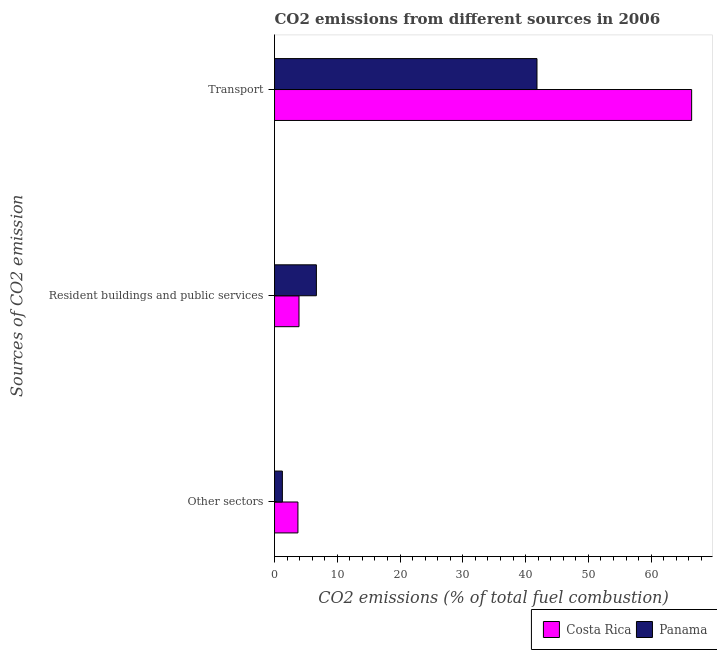How many different coloured bars are there?
Your response must be concise. 2. Are the number of bars per tick equal to the number of legend labels?
Provide a short and direct response. Yes. How many bars are there on the 1st tick from the bottom?
Keep it short and to the point. 2. What is the label of the 2nd group of bars from the top?
Provide a short and direct response. Resident buildings and public services. What is the percentage of co2 emissions from other sectors in Costa Rica?
Your answer should be compact. 3.73. Across all countries, what is the maximum percentage of co2 emissions from other sectors?
Provide a short and direct response. 3.73. Across all countries, what is the minimum percentage of co2 emissions from resident buildings and public services?
Provide a short and direct response. 3.9. In which country was the percentage of co2 emissions from resident buildings and public services maximum?
Give a very brief answer. Panama. In which country was the percentage of co2 emissions from transport minimum?
Your response must be concise. Panama. What is the total percentage of co2 emissions from other sectors in the graph?
Your answer should be compact. 4.98. What is the difference between the percentage of co2 emissions from transport in Panama and that in Costa Rica?
Offer a terse response. -24.64. What is the difference between the percentage of co2 emissions from transport in Costa Rica and the percentage of co2 emissions from other sectors in Panama?
Give a very brief answer. 65.19. What is the average percentage of co2 emissions from transport per country?
Your response must be concise. 54.12. What is the difference between the percentage of co2 emissions from transport and percentage of co2 emissions from other sectors in Costa Rica?
Offer a very short reply. 62.71. What is the ratio of the percentage of co2 emissions from resident buildings and public services in Costa Rica to that in Panama?
Make the answer very short. 0.58. Is the percentage of co2 emissions from resident buildings and public services in Costa Rica less than that in Panama?
Ensure brevity in your answer.  Yes. Is the difference between the percentage of co2 emissions from resident buildings and public services in Costa Rica and Panama greater than the difference between the percentage of co2 emissions from transport in Costa Rica and Panama?
Your response must be concise. No. What is the difference between the highest and the second highest percentage of co2 emissions from transport?
Your answer should be compact. 24.64. What is the difference between the highest and the lowest percentage of co2 emissions from transport?
Your answer should be compact. 24.64. In how many countries, is the percentage of co2 emissions from other sectors greater than the average percentage of co2 emissions from other sectors taken over all countries?
Offer a terse response. 1. What does the 2nd bar from the top in Other sectors represents?
Your answer should be very brief. Costa Rica. What does the 2nd bar from the bottom in Transport represents?
Give a very brief answer. Panama. Is it the case that in every country, the sum of the percentage of co2 emissions from other sectors and percentage of co2 emissions from resident buildings and public services is greater than the percentage of co2 emissions from transport?
Make the answer very short. No. How many bars are there?
Your answer should be compact. 6. What is the difference between two consecutive major ticks on the X-axis?
Keep it short and to the point. 10. Are the values on the major ticks of X-axis written in scientific E-notation?
Provide a succinct answer. No. Does the graph contain grids?
Provide a short and direct response. No. How are the legend labels stacked?
Provide a succinct answer. Horizontal. What is the title of the graph?
Give a very brief answer. CO2 emissions from different sources in 2006. What is the label or title of the X-axis?
Your answer should be very brief. CO2 emissions (% of total fuel combustion). What is the label or title of the Y-axis?
Offer a very short reply. Sources of CO2 emission. What is the CO2 emissions (% of total fuel combustion) in Costa Rica in Other sectors?
Offer a very short reply. 3.73. What is the CO2 emissions (% of total fuel combustion) in Costa Rica in Resident buildings and public services?
Your response must be concise. 3.9. What is the CO2 emissions (% of total fuel combustion) of Panama in Resident buildings and public services?
Offer a very short reply. 6.67. What is the CO2 emissions (% of total fuel combustion) of Costa Rica in Transport?
Offer a very short reply. 66.44. What is the CO2 emissions (% of total fuel combustion) of Panama in Transport?
Ensure brevity in your answer.  41.81. Across all Sources of CO2 emission, what is the maximum CO2 emissions (% of total fuel combustion) in Costa Rica?
Your answer should be compact. 66.44. Across all Sources of CO2 emission, what is the maximum CO2 emissions (% of total fuel combustion) in Panama?
Provide a succinct answer. 41.81. Across all Sources of CO2 emission, what is the minimum CO2 emissions (% of total fuel combustion) of Costa Rica?
Offer a terse response. 3.73. What is the total CO2 emissions (% of total fuel combustion) in Costa Rica in the graph?
Provide a succinct answer. 74.07. What is the total CO2 emissions (% of total fuel combustion) in Panama in the graph?
Offer a very short reply. 49.72. What is the difference between the CO2 emissions (% of total fuel combustion) in Costa Rica in Other sectors and that in Resident buildings and public services?
Your answer should be compact. -0.17. What is the difference between the CO2 emissions (% of total fuel combustion) of Panama in Other sectors and that in Resident buildings and public services?
Provide a short and direct response. -5.42. What is the difference between the CO2 emissions (% of total fuel combustion) in Costa Rica in Other sectors and that in Transport?
Ensure brevity in your answer.  -62.71. What is the difference between the CO2 emissions (% of total fuel combustion) in Panama in Other sectors and that in Transport?
Your answer should be compact. -40.56. What is the difference between the CO2 emissions (% of total fuel combustion) in Costa Rica in Resident buildings and public services and that in Transport?
Offer a very short reply. -62.54. What is the difference between the CO2 emissions (% of total fuel combustion) of Panama in Resident buildings and public services and that in Transport?
Your response must be concise. -35.14. What is the difference between the CO2 emissions (% of total fuel combustion) of Costa Rica in Other sectors and the CO2 emissions (% of total fuel combustion) of Panama in Resident buildings and public services?
Make the answer very short. -2.94. What is the difference between the CO2 emissions (% of total fuel combustion) in Costa Rica in Other sectors and the CO2 emissions (% of total fuel combustion) in Panama in Transport?
Offer a terse response. -38.08. What is the difference between the CO2 emissions (% of total fuel combustion) of Costa Rica in Resident buildings and public services and the CO2 emissions (% of total fuel combustion) of Panama in Transport?
Offer a very short reply. -37.91. What is the average CO2 emissions (% of total fuel combustion) in Costa Rica per Sources of CO2 emission?
Your response must be concise. 24.69. What is the average CO2 emissions (% of total fuel combustion) of Panama per Sources of CO2 emission?
Keep it short and to the point. 16.57. What is the difference between the CO2 emissions (% of total fuel combustion) of Costa Rica and CO2 emissions (% of total fuel combustion) of Panama in Other sectors?
Your response must be concise. 2.48. What is the difference between the CO2 emissions (% of total fuel combustion) of Costa Rica and CO2 emissions (% of total fuel combustion) of Panama in Resident buildings and public services?
Provide a short and direct response. -2.77. What is the difference between the CO2 emissions (% of total fuel combustion) in Costa Rica and CO2 emissions (% of total fuel combustion) in Panama in Transport?
Offer a very short reply. 24.64. What is the ratio of the CO2 emissions (% of total fuel combustion) of Costa Rica in Other sectors to that in Resident buildings and public services?
Provide a short and direct response. 0.96. What is the ratio of the CO2 emissions (% of total fuel combustion) of Panama in Other sectors to that in Resident buildings and public services?
Ensure brevity in your answer.  0.19. What is the ratio of the CO2 emissions (% of total fuel combustion) in Costa Rica in Other sectors to that in Transport?
Provide a short and direct response. 0.06. What is the ratio of the CO2 emissions (% of total fuel combustion) in Panama in Other sectors to that in Transport?
Offer a terse response. 0.03. What is the ratio of the CO2 emissions (% of total fuel combustion) of Costa Rica in Resident buildings and public services to that in Transport?
Make the answer very short. 0.06. What is the ratio of the CO2 emissions (% of total fuel combustion) of Panama in Resident buildings and public services to that in Transport?
Provide a succinct answer. 0.16. What is the difference between the highest and the second highest CO2 emissions (% of total fuel combustion) of Costa Rica?
Your answer should be compact. 62.54. What is the difference between the highest and the second highest CO2 emissions (% of total fuel combustion) in Panama?
Provide a succinct answer. 35.14. What is the difference between the highest and the lowest CO2 emissions (% of total fuel combustion) in Costa Rica?
Provide a succinct answer. 62.71. What is the difference between the highest and the lowest CO2 emissions (% of total fuel combustion) in Panama?
Ensure brevity in your answer.  40.56. 